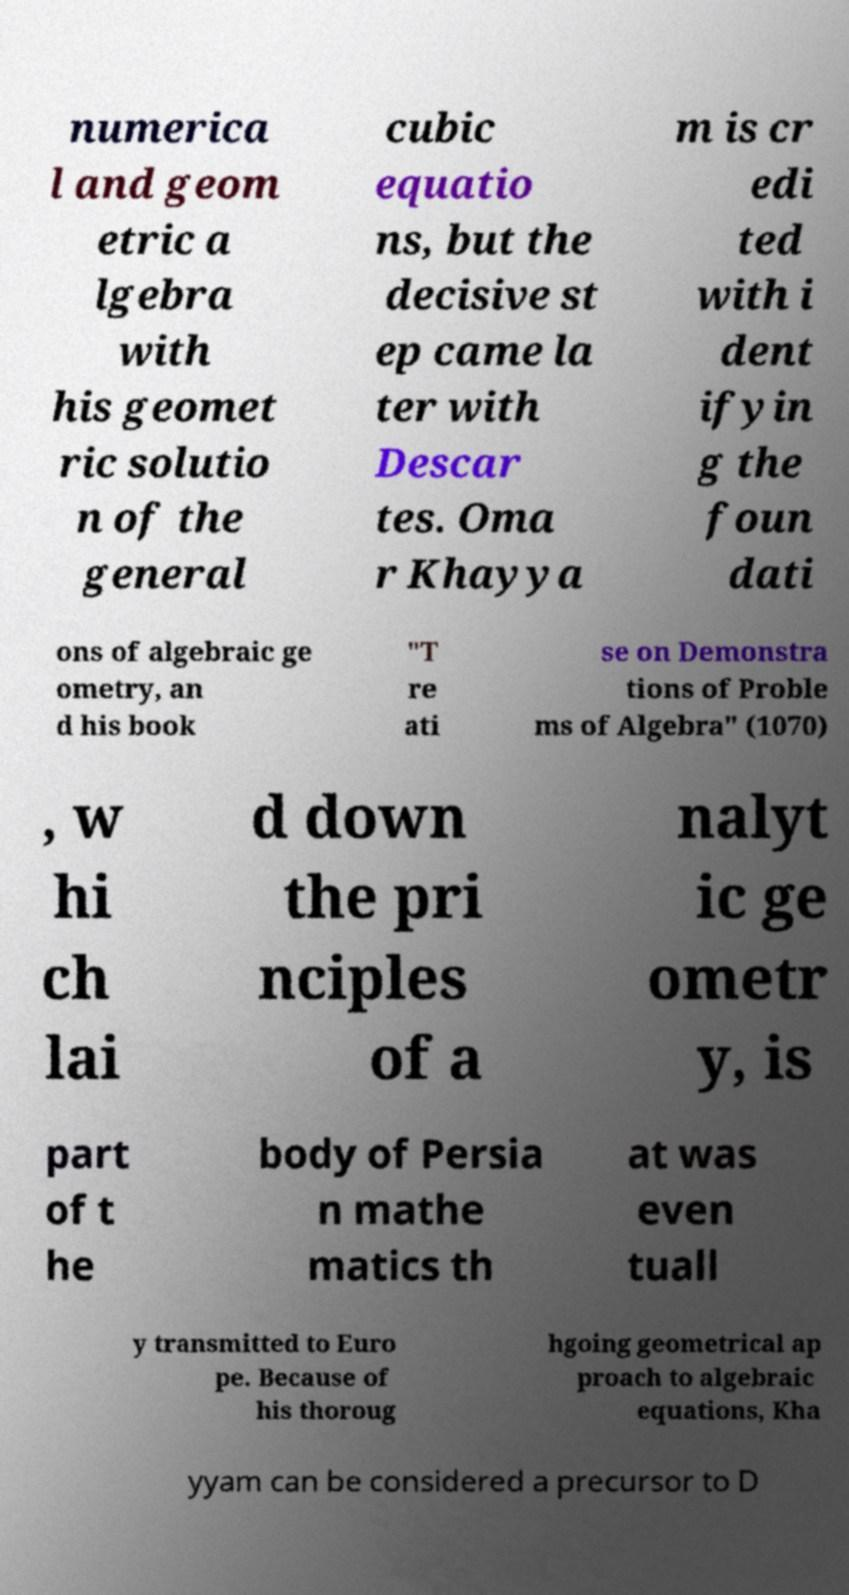There's text embedded in this image that I need extracted. Can you transcribe it verbatim? numerica l and geom etric a lgebra with his geomet ric solutio n of the general cubic equatio ns, but the decisive st ep came la ter with Descar tes. Oma r Khayya m is cr edi ted with i dent ifyin g the foun dati ons of algebraic ge ometry, an d his book "T re ati se on Demonstra tions of Proble ms of Algebra" (1070) , w hi ch lai d down the pri nciples of a nalyt ic ge ometr y, is part of t he body of Persia n mathe matics th at was even tuall y transmitted to Euro pe. Because of his thoroug hgoing geometrical ap proach to algebraic equations, Kha yyam can be considered a precursor to D 